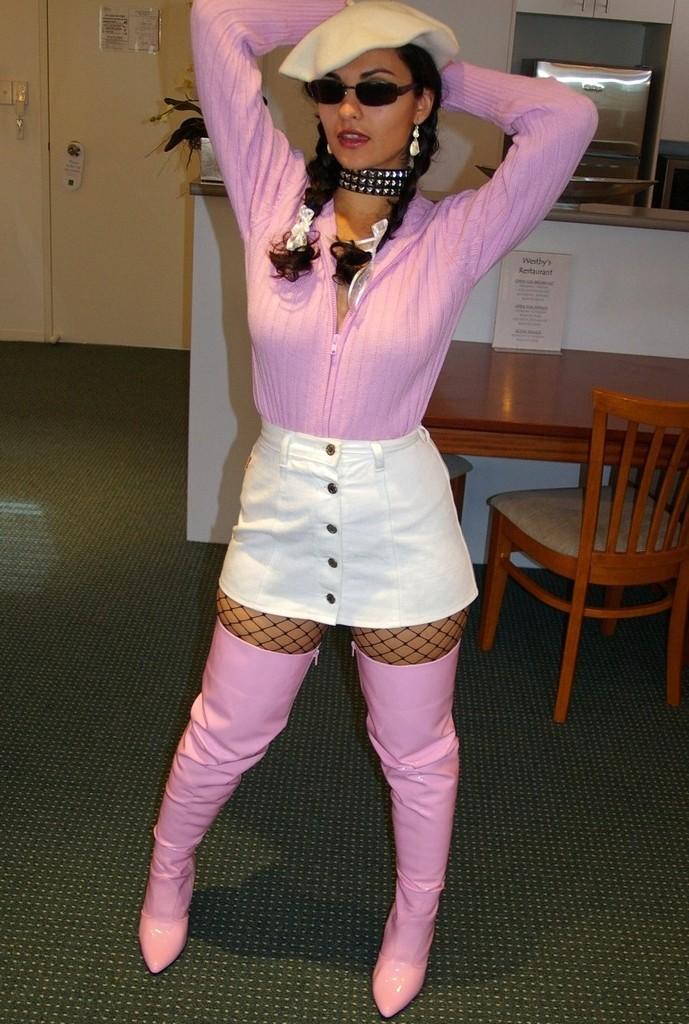How would you summarize this image in a sentence or two? A lady with pink and white dress is stunning. She is wearing a cap on her head and she kept googles. At the back of her there is a table with card on it. There are two chairs. And to the left side there is a door. To the right side top corner there is a oven. 